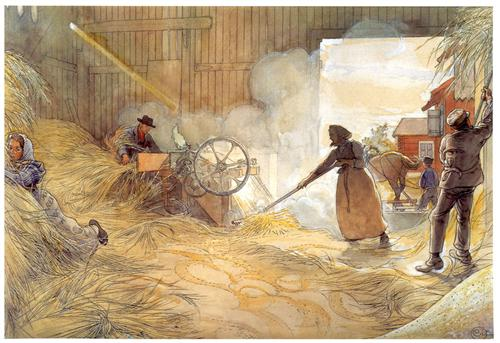What are the emotions conveyed by the people in the painting? The emotions conveyed by the people in the painting range from concentration and determination to a quiet sense of satisfaction. The individuals are deeply absorbed in their work, reflecting a strong work ethic and dedication. Despite the laborious task, there is a sense of community spirit and cooperation among them. The warm lighting and the peaceful, rustic setting contribute to an overall atmosphere of tranquility and fulfillment, indicating that the people take pride in their work and find contentment in their shared endeavor. 